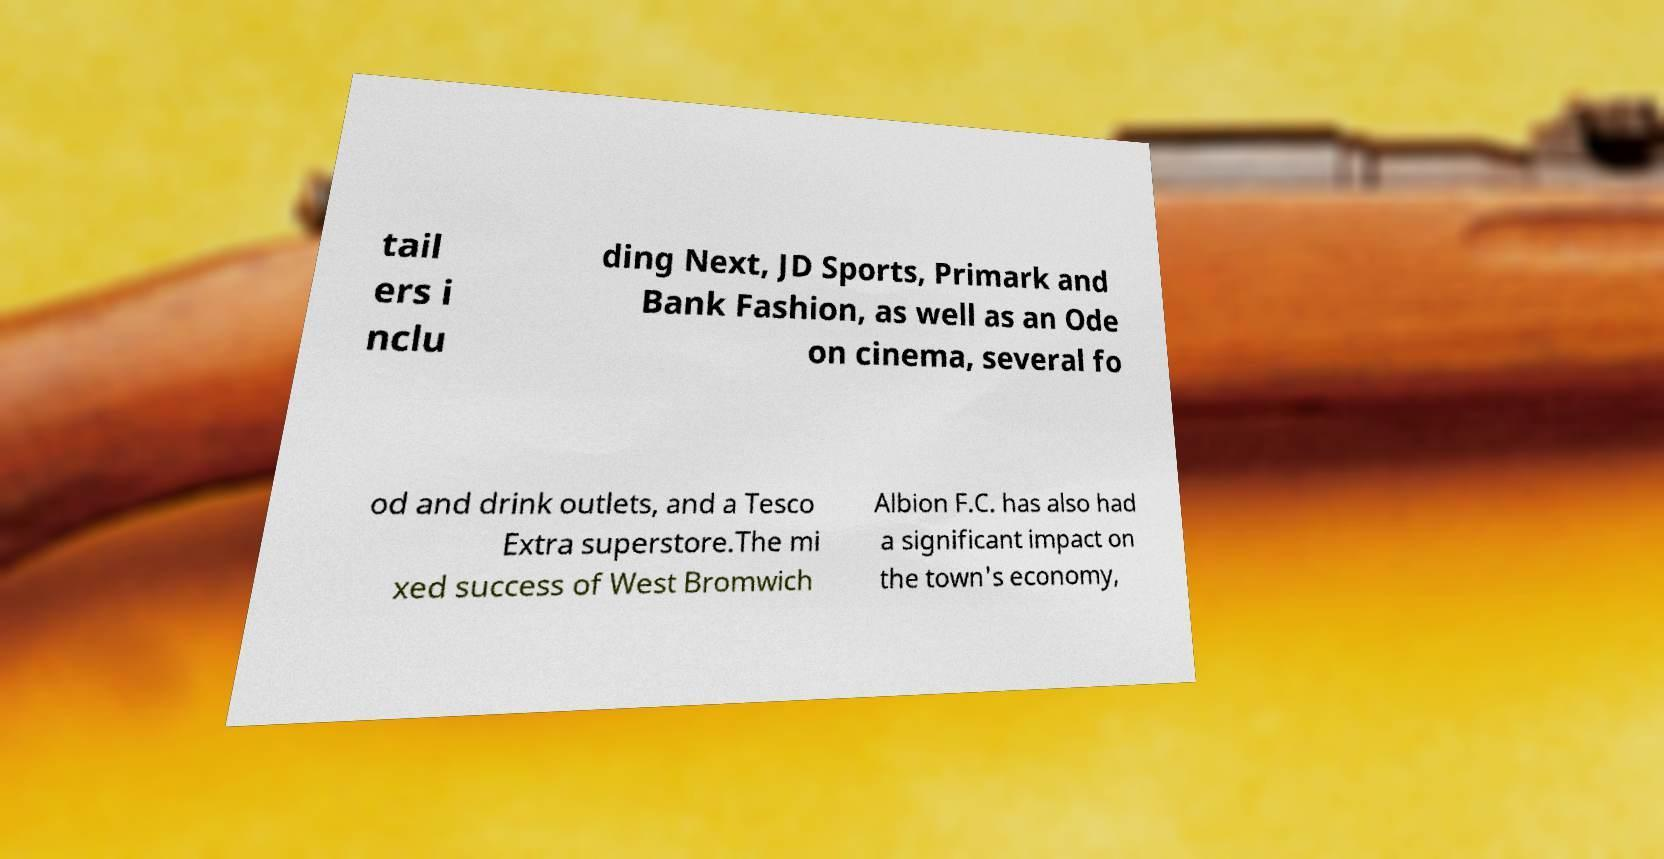Please read and relay the text visible in this image. What does it say? tail ers i nclu ding Next, JD Sports, Primark and Bank Fashion, as well as an Ode on cinema, several fo od and drink outlets, and a Tesco Extra superstore.The mi xed success of West Bromwich Albion F.C. has also had a significant impact on the town's economy, 